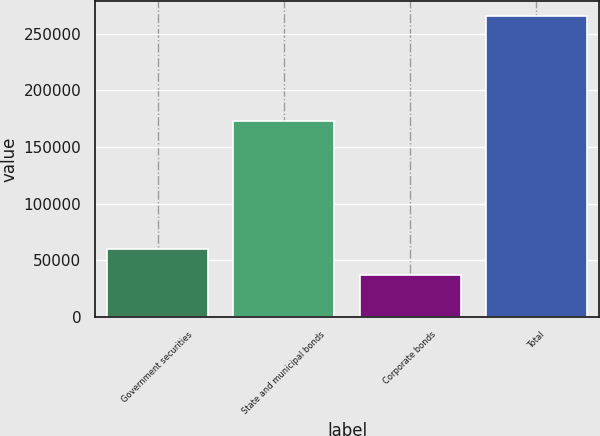Convert chart. <chart><loc_0><loc_0><loc_500><loc_500><bar_chart><fcel>Government securities<fcel>State and municipal bonds<fcel>Corporate bonds<fcel>Total<nl><fcel>60377.4<fcel>173501<fcel>37596<fcel>265410<nl></chart> 